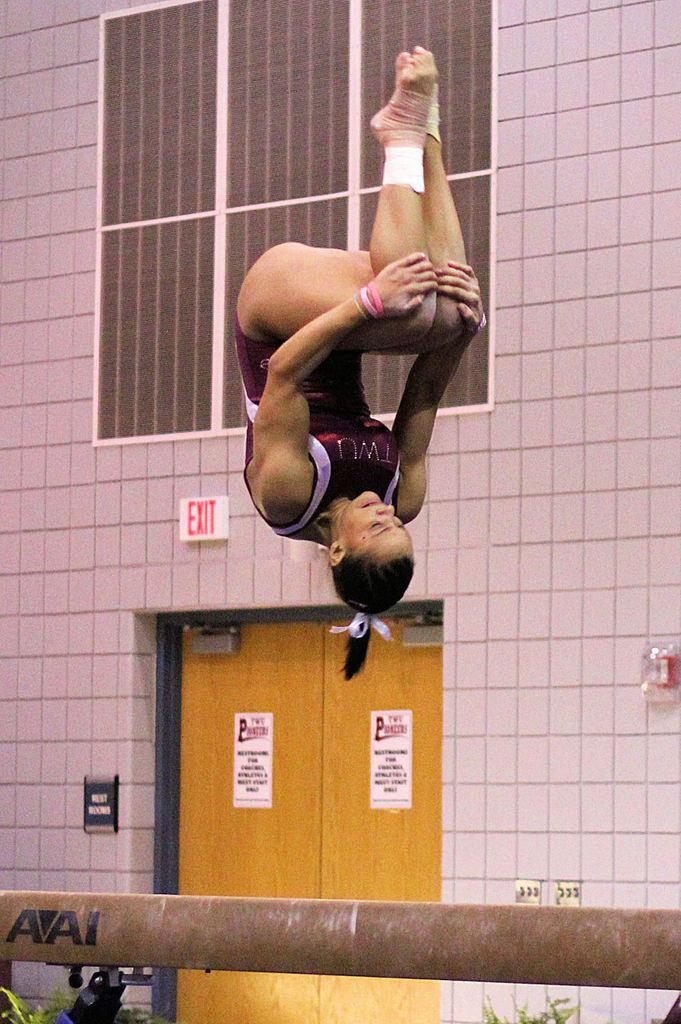What is the main object in the image? There is a balancing beam in the image. What is happening on the balancing beam? A lady is doing gymnastics on the beam. What can be seen in the background of the image? There is a wall in the background of the image. What features does the wall have? The wall has a door and windows. What is specifically related to gymnastics on the wall? There is an exit board on the wall. How many chickens are present in the image? There are no chickens present in the image. What type of knee injury does the lady have while doing gymnastics? There is no indication of any injury in the image, and we cannot determine the lady's knee condition. 